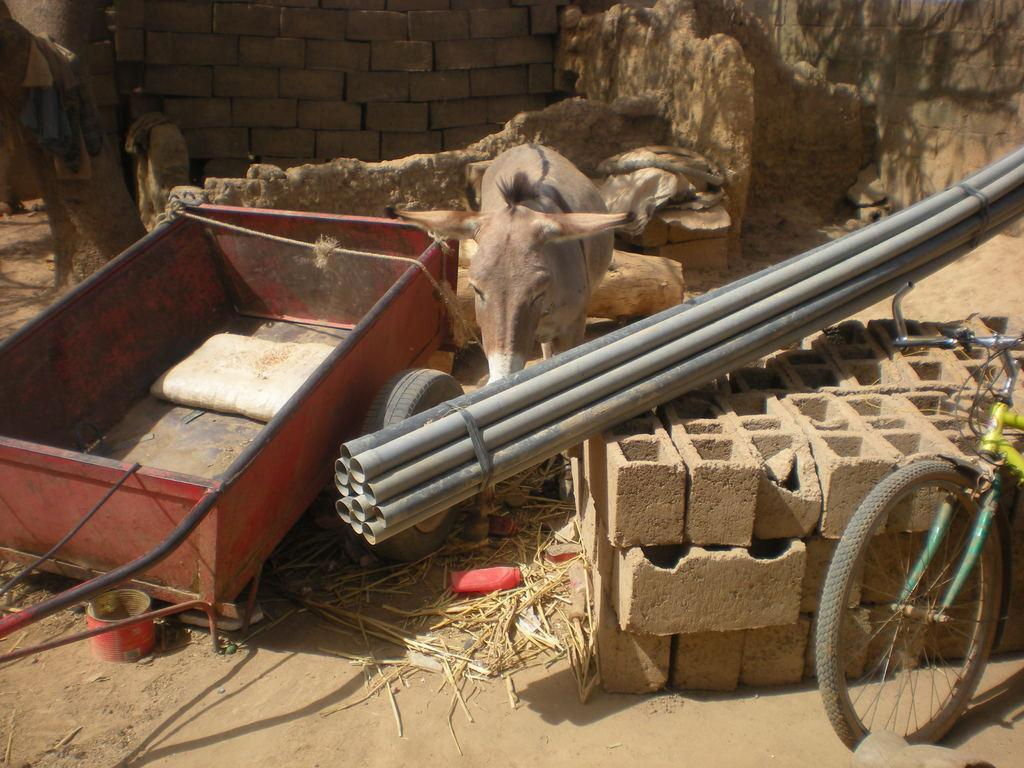What type of animal can be seen in the image? There is a donkey in the image. What objects are present in the image that are related to construction or plumbing? There are pipes and bricks visible in the image. What mode of transportation can be seen in the image? There is a bicycle in the image. What type of vegetation is present in the image? There is grass in the image. What is on the ground in the image? There is a cart on the ground in the image. What can be seen in the background of the image? There is a wall visible in the background of the image. How many cents are visible on the donkey's stomach in the image? There are no cents visible on the donkey's stomach in the image, as donkeys do not have currency attached to their bodies. 